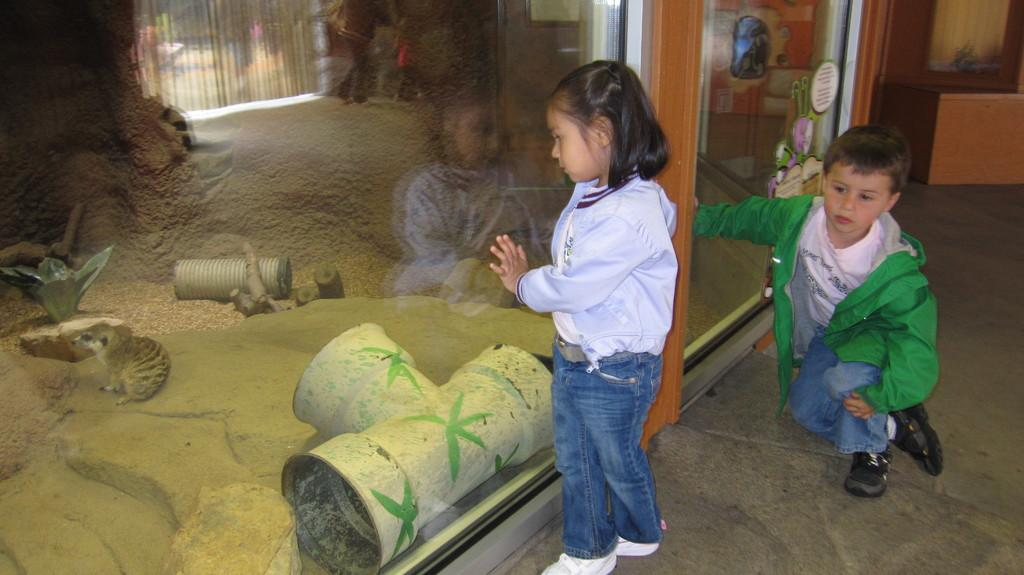How many kids are in the image? There are two kids in the center of the image. What is located to the left side of the kids in the image? There is a glass to the left side of the image. What type of surface is visible at the bottom of the image? There is flooring at the bottom of the image. What type of veil is being used by the kids in the image? There is no veil present in the image; the kids are not wearing any veils. 